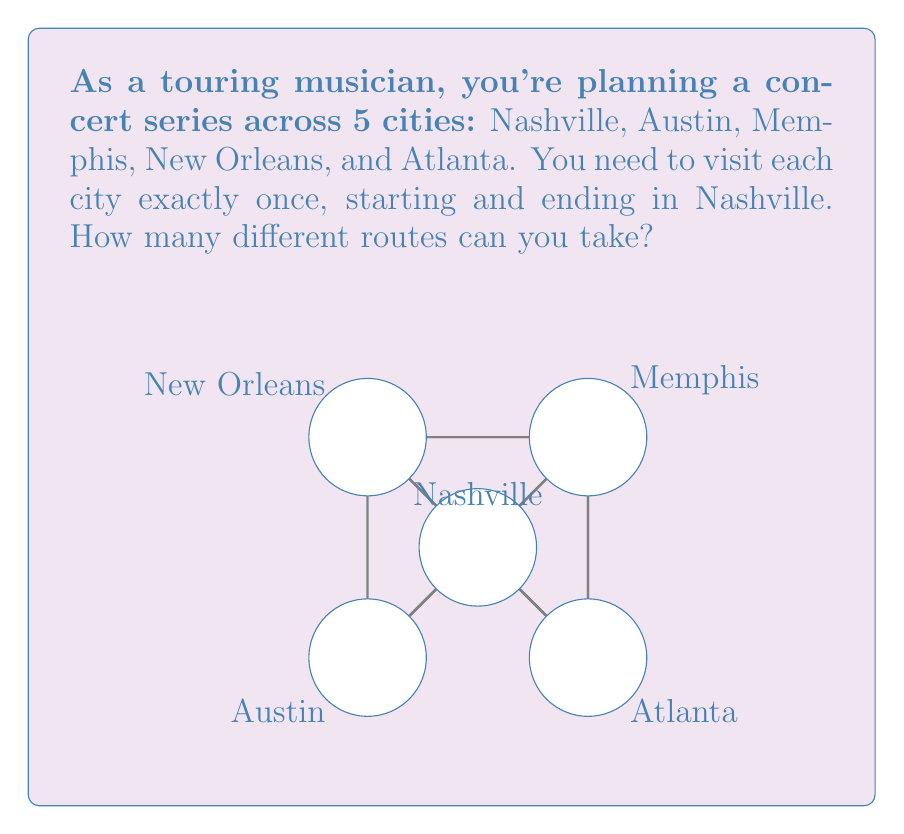Could you help me with this problem? Let's approach this step-by-step:

1) We start in Nashville and end in Nashville, so we only need to consider the order of visiting the other 4 cities.

2) This is a permutation problem. We need to calculate how many ways we can arrange 4 cities.

3) The number of permutations of n distinct objects is given by the factorial of n, denoted as n!

4) In this case, n = 4, so we need to calculate 4!

5) 4! is calculated as follows:
   $$4! = 4 \times 3 \times 2 \times 1 = 24$$

6) Therefore, there are 24 different routes you can take.

Note: This problem is analogous to the Traveling Salesman Problem, which is often encountered in logistics and tour planning. As a touring musician, understanding these concepts can help in efficient route planning for concert tours.
Answer: 24 routes 